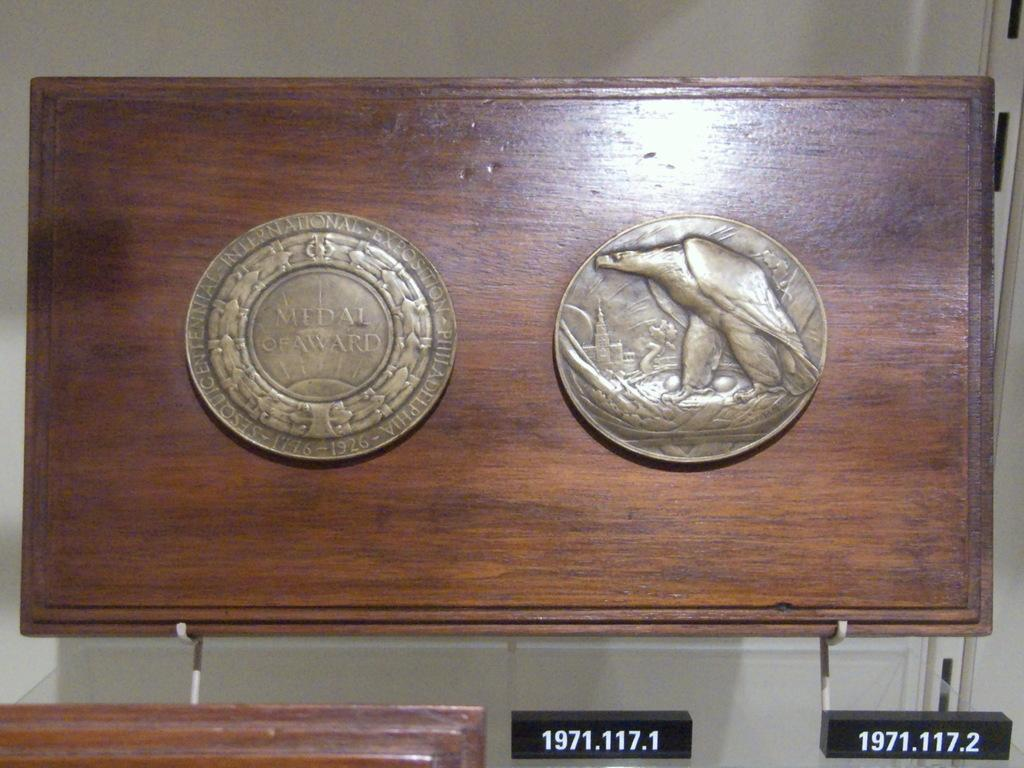<image>
Describe the image concisely. The first coin shown celebrates something from 1776-1926. 